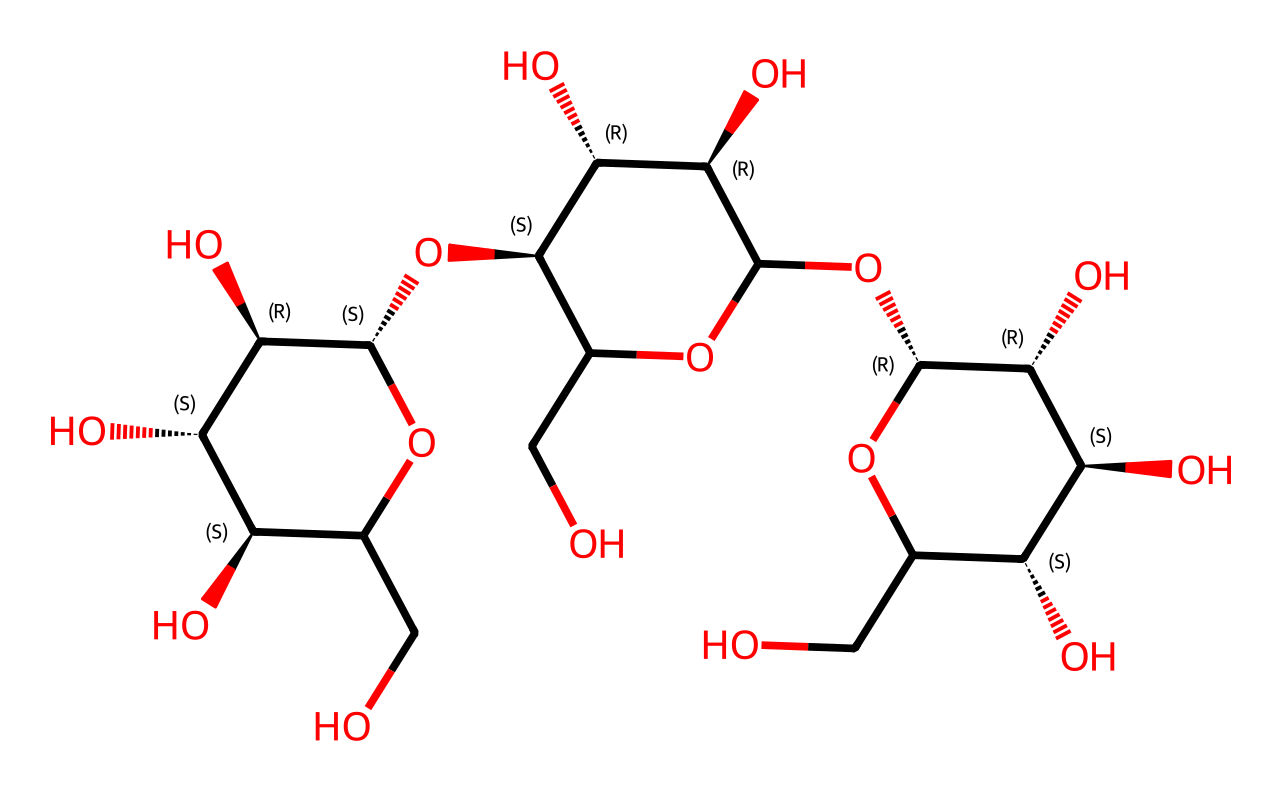What is the most prominent functional group in cellulose? In the given SMILES, we can observe multiple hydroxyl groups (-OH) attached to the carbon rings. This is indicative of a polysaccharide structure, especially cellulose, which is characterized by these numerous -OH groups contributing to its physical properties.
Answer: hydroxyl group How many carbon atoms are present in the chemical structure of cellulose? By analyzing the structure provided in the SMILES, we can count the number of carbon atoms in the repeating units of the cellulose polymer. Upon inspection of each segment, we find that there are 6 carbon atoms present in one glucose unit, and given the nature of cellulose, we can identify multiple repeating units. Overall, we can expect around 12 carbon atoms in the display.
Answer: 12 Is the cellulose structure branched or linear? Reviewing the SMILES representation, we observe that the structure forms a linear arrangement with linked glucose units through β(1→4) glycosidic bonds. There are no side chains or branching points evident in the structure. Therefore, cellulose maintains a straight-chain formation, typical of its function in supporting plant structure.
Answer: linear What is the average degree of polymerization for cellulose? Cellulose is a polymer made up of repeated glucose units; typically, cellulose can have a degree of polymerization ranging from 300 to 10,000 monomer units in its structure. In this case, we assess the representation closely, estimating an average around 1,000 based on the complexity of the structure drawn from the SMILES notation.
Answer: 1000 What type of linkage connects the glucose units in cellulose? Examining the SMILES representation, we can identify that the linkages between the glucose units are formed by specific bonds, namely the β(1→4) glycosidic bonds. This type of linkage is essential for the structural integrity of cellulose and contributes to its resistance to digestion by most organisms.
Answer: β(1→4) glycosidic linkage 